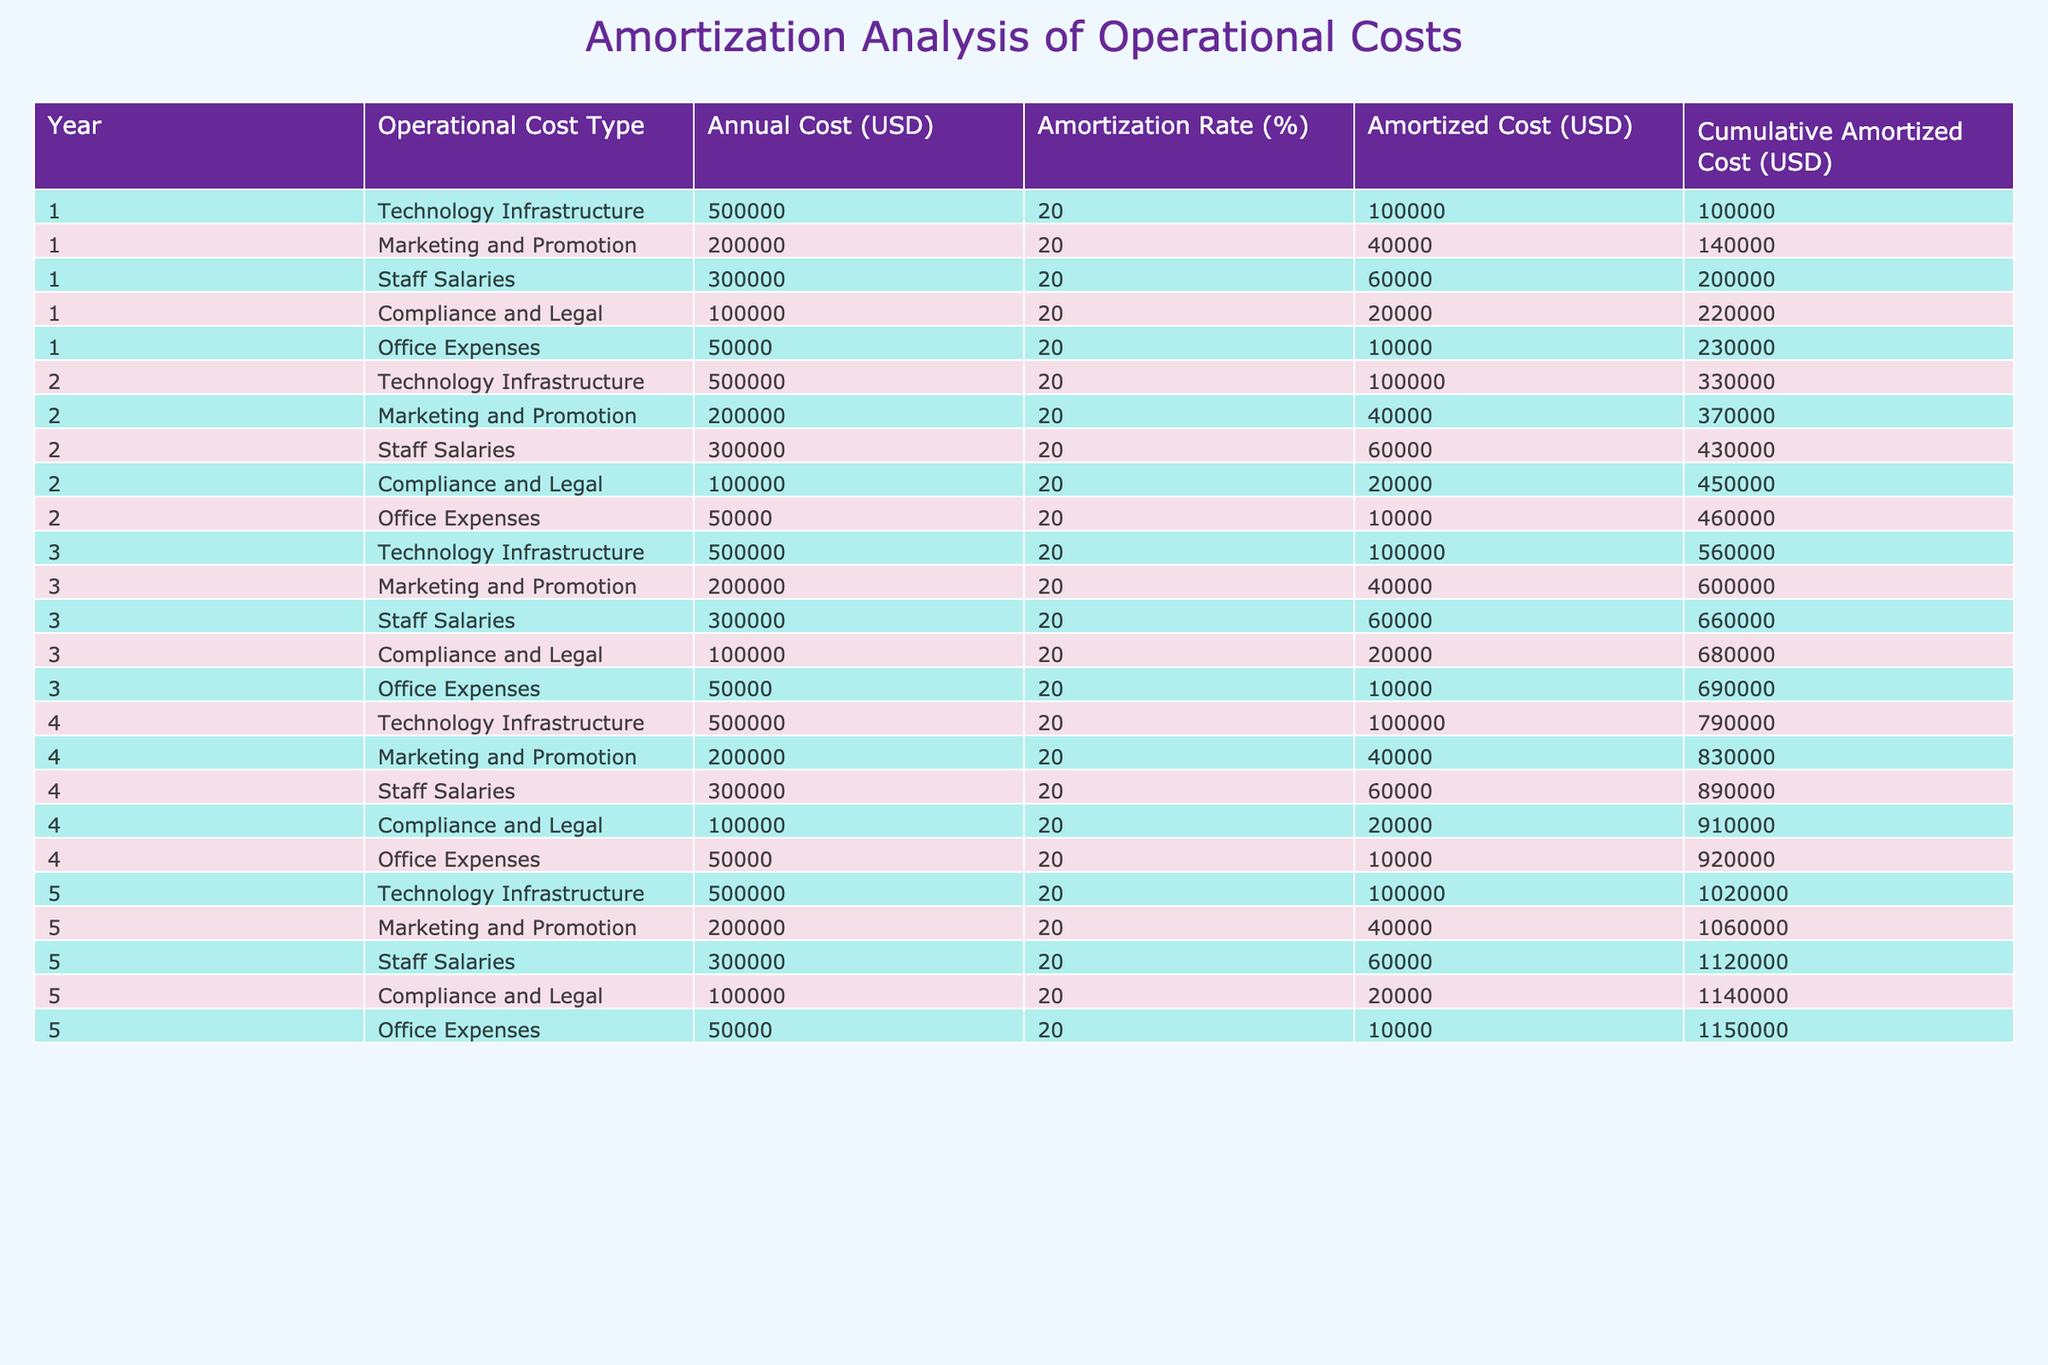What is the total operational cost for Year 1? The total operational cost for Year 1 can be calculated by summing the annual costs of all operational cost types in that year: 500000 (Technology Infrastructure) + 200000 (Marketing and Promotion) + 300000 (Staff Salaries) + 100000 (Compliance and Legal) + 50000 (Office Expenses) = 1150000.
Answer: 1150000 What is the annual amortized cost for Marketing and Promotion in Year 3? According to the table, the annual amortized cost for Marketing and Promotion in Year 3 is listed directly under that heading, which is 40000.
Answer: 40000 Is the cumulative amortized cost higher in Year 4 than in Year 5? To compare the cumulative amortized costs, the values for Year 4 and Year 5 must be checked: Year 4 cumulative amortized cost is 920000 and Year 5 cumulative amortized cost is 1150000. Since 920000 is less than 1150000, the statement is false.
Answer: No What is the percentage of cumulative amortized cost that comes from Staff Salaries after Year 4? First, we find the cumulative amortized cost for Staff Salaries after Year 4, which is 890000. The total cumulative amortized cost in Year 4 is 920000. To find the percentage, we calculate (890000 / 920000) * 100 = 96.74%. So, approximately 96.74% of the cumulative amortized cost comes from Staff Salaries after Year 4.
Answer: 96.74% How much did the cumulative amortized cost increase from Year 2 to Year 3? The cumulative amortized cost for Year 2 is 460000 and for Year 3 is 690000. To find the increase, subtract Year 2 from Year 3: 690000 - 460000 = 230000. Thus, the cumulative amortized cost increased by 230000 from Year 2 to Year 3.
Answer: 230000 What is the total amortized cost for Technology Infrastructure over the 5 years? The total amortized cost for Technology Infrastructure can be calculated by adding the amortized costs for each year: 100000 (Year 1) + 100000 (Year 2) + 100000 (Year 3) + 100000 (Year 4) + 100000 (Year 5) = 500000.
Answer: 500000 Which operational cost type has the highest cumulative amortized cost by Year 5? By examining the cumulative amortized costs for each cost type by Year 5, it’s clear that Staff Salaries has the highest cumulative amortized cost of 1120000.
Answer: Staff Salaries What was the total increase in cumulative amortized cost from Year 1 to Year 5? To find this, we subtract the cumulative amortized cost for Year 1 from that for Year 5: 1150000 (Year 5) - 230000 (Year 1) = 920000. Thus, the total increase in cumulative amortized cost from Year 1 to Year 5 is 920000.
Answer: 920000 